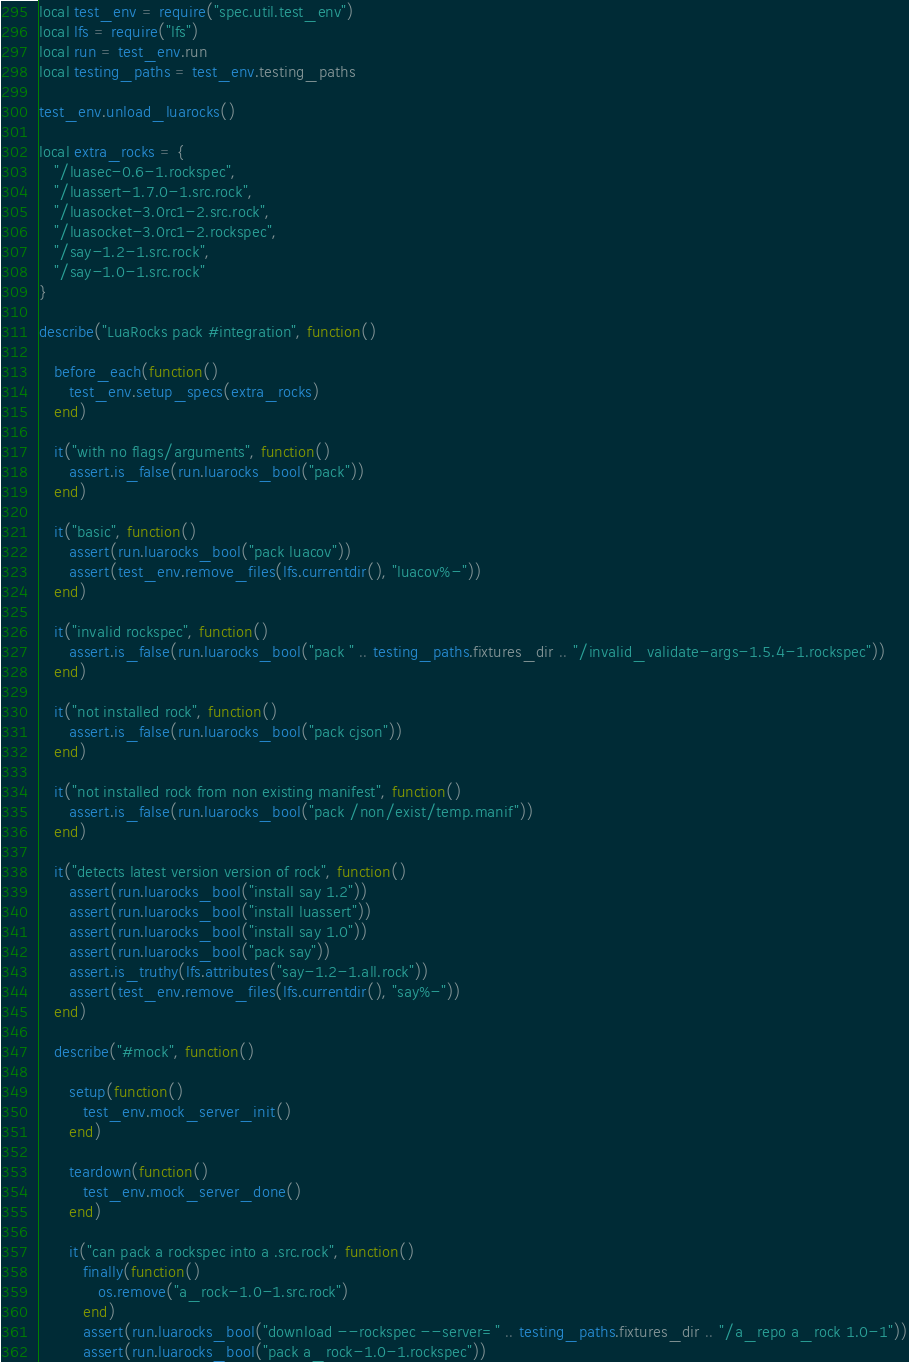<code> <loc_0><loc_0><loc_500><loc_500><_Lua_>local test_env = require("spec.util.test_env")
local lfs = require("lfs")
local run = test_env.run
local testing_paths = test_env.testing_paths

test_env.unload_luarocks()

local extra_rocks = {
   "/luasec-0.6-1.rockspec",
   "/luassert-1.7.0-1.src.rock",
   "/luasocket-3.0rc1-2.src.rock",
   "/luasocket-3.0rc1-2.rockspec",
   "/say-1.2-1.src.rock",
   "/say-1.0-1.src.rock"
}

describe("LuaRocks pack #integration", function()

   before_each(function()
      test_env.setup_specs(extra_rocks)
   end)

   it("with no flags/arguments", function()
      assert.is_false(run.luarocks_bool("pack"))
   end)

   it("basic", function()
      assert(run.luarocks_bool("pack luacov"))
      assert(test_env.remove_files(lfs.currentdir(), "luacov%-"))
   end)

   it("invalid rockspec", function()
      assert.is_false(run.luarocks_bool("pack " .. testing_paths.fixtures_dir .. "/invalid_validate-args-1.5.4-1.rockspec"))
   end)

   it("not installed rock", function()
      assert.is_false(run.luarocks_bool("pack cjson"))
   end)
   
   it("not installed rock from non existing manifest", function()
      assert.is_false(run.luarocks_bool("pack /non/exist/temp.manif"))
   end)

   it("detects latest version version of rock", function()
      assert(run.luarocks_bool("install say 1.2"))
      assert(run.luarocks_bool("install luassert"))
      assert(run.luarocks_bool("install say 1.0"))
      assert(run.luarocks_bool("pack say"))
      assert.is_truthy(lfs.attributes("say-1.2-1.all.rock"))
      assert(test_env.remove_files(lfs.currentdir(), "say%-"))
   end)

   describe("#mock", function()

      setup(function()
         test_env.mock_server_init()
      end)
      
      teardown(function()
         test_env.mock_server_done()
      end)

      it("can pack a rockspec into a .src.rock", function()
         finally(function()
            os.remove("a_rock-1.0-1.src.rock")
         end)
         assert(run.luarocks_bool("download --rockspec --server=" .. testing_paths.fixtures_dir .. "/a_repo a_rock 1.0-1"))
         assert(run.luarocks_bool("pack a_rock-1.0-1.rockspec"))</code> 